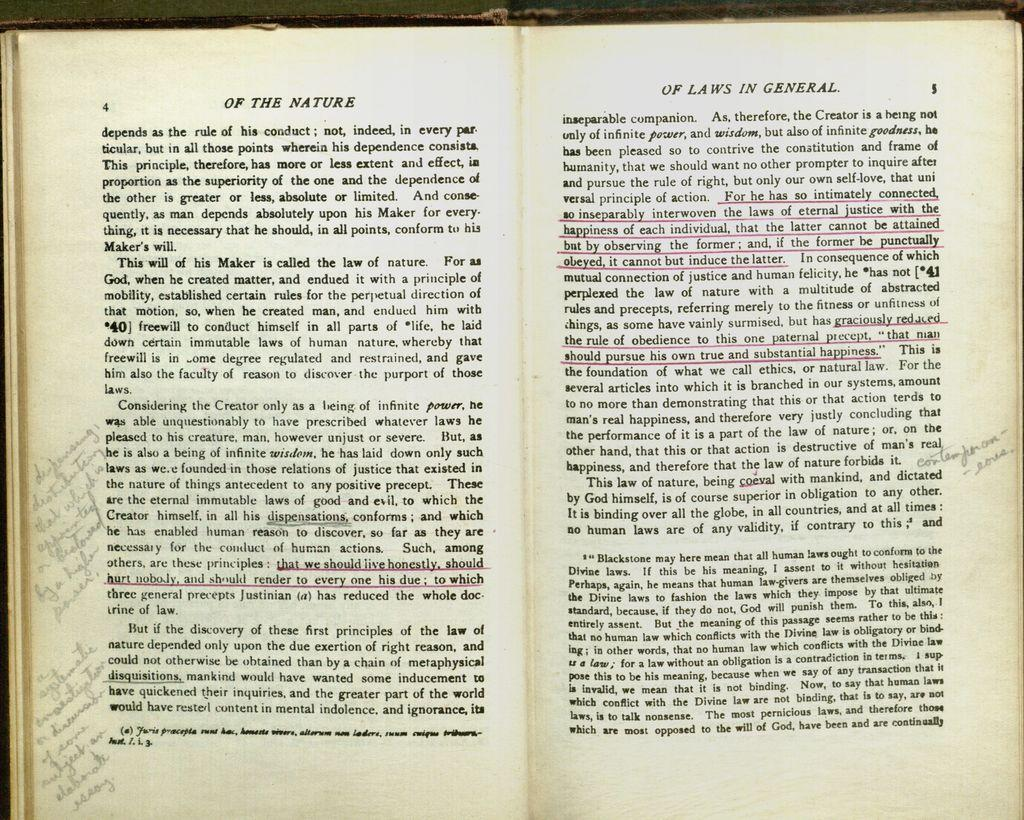<image>
Offer a succinct explanation of the picture presented. A book open to pages 4 and 5 "Of the Nature Of Laws in General" 